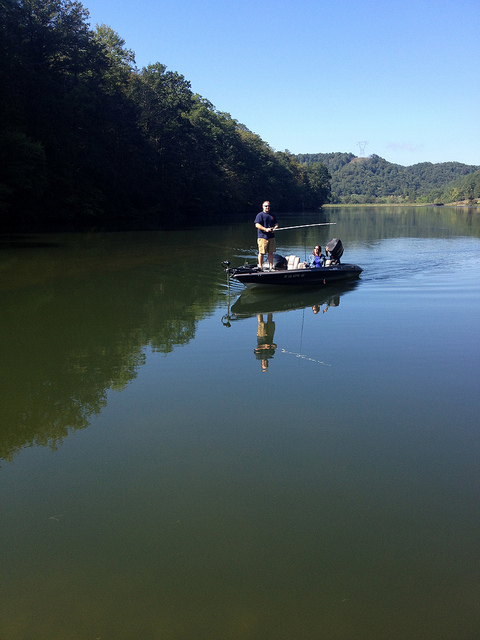<image>What is the motion of the water? The motion of the water is unclear. It could be still, calm, chop or there might be a boat in the water. What is the motion of the water? The motion of the water is calm. 